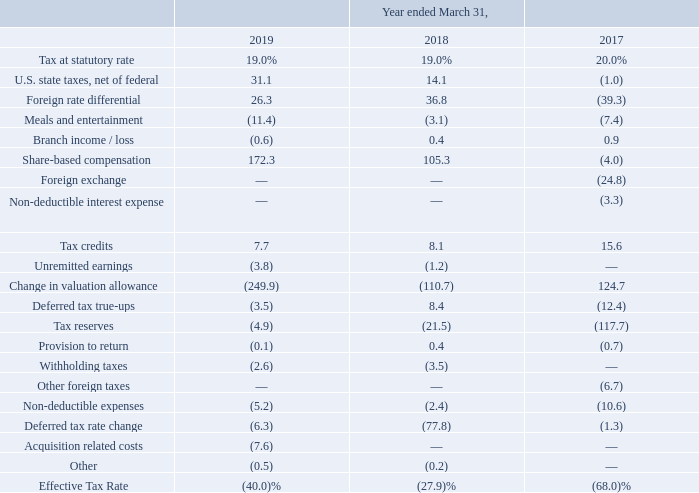The reconciliation of the United Kingdom statutory tax rate to the Company’s effective tax rate included in the accompanying consolidated statements of operations is as follows:
Although the Company’s parent entity is organized under Jersey law, our affairs are, and are intended to be, managed and controlled ongoing in the United Kingdom. Therefore, the Company is resident in the United Kingdom for tax purposes. The Company’s parent entity is domiciled in the United Kingdom and its earnings are subject to 19%, 19% and 20% statutory tax rate for the years ended March 31, 2019, 2018 and 2017, respectively.
The Company’s effective tax rate differs from the statutory rate each year primarily due to windfall tax benefits on equity award exercises, the valuation allowance maintained against the Company’s net deferred tax assets, the jurisdictional earnings mix, tax credits, withholding taxes, and other permanent differences primarily related to non-deductible expenses.
Which country controls the company's affairs? United kingdom. What is the reason for the company's effective tax to differ from the statutory rate? Primarily due to windfall tax benefits on equity award exercises, the valuation allowance maintained against the company’s net deferred tax assets, the jurisdictional earnings mix, tax credits, withholding taxes, and other permanent differences primarily related to non-deductible expenses. What was the Tax at statutory rate in 2019, 2018 and 2017 respectively? 19.0%, 19.0%, 20.0%. What was the change in the U.S. state taxes, net of federal from 2018 to 2019?
Answer scale should be: percent. 31.1 - 14.1
Answer: 17. What was the average Share-based compensation between 2017-2019?
Answer scale should be: percent. (172.3 + 105.3 - 4.0) / 3
Answer: 91.2. In which year was Tax credits less than 10.0? Locate and analyze tax credits in row 11
answer: 2019, 2018. 